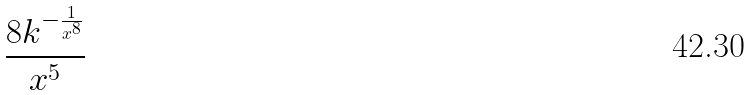Convert formula to latex. <formula><loc_0><loc_0><loc_500><loc_500>\frac { 8 k ^ { - \frac { 1 } { x ^ { 8 } } } } { x ^ { 5 } }</formula> 